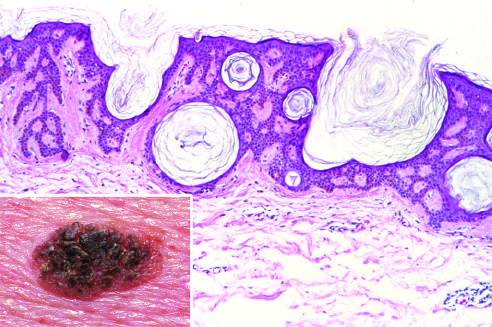what shows an orderly proliferation of uniform, basaloid keratinocytes that tend to form keratin microcysts horn cysts?
Answer the question using a single word or phrase. Microscopic examination 